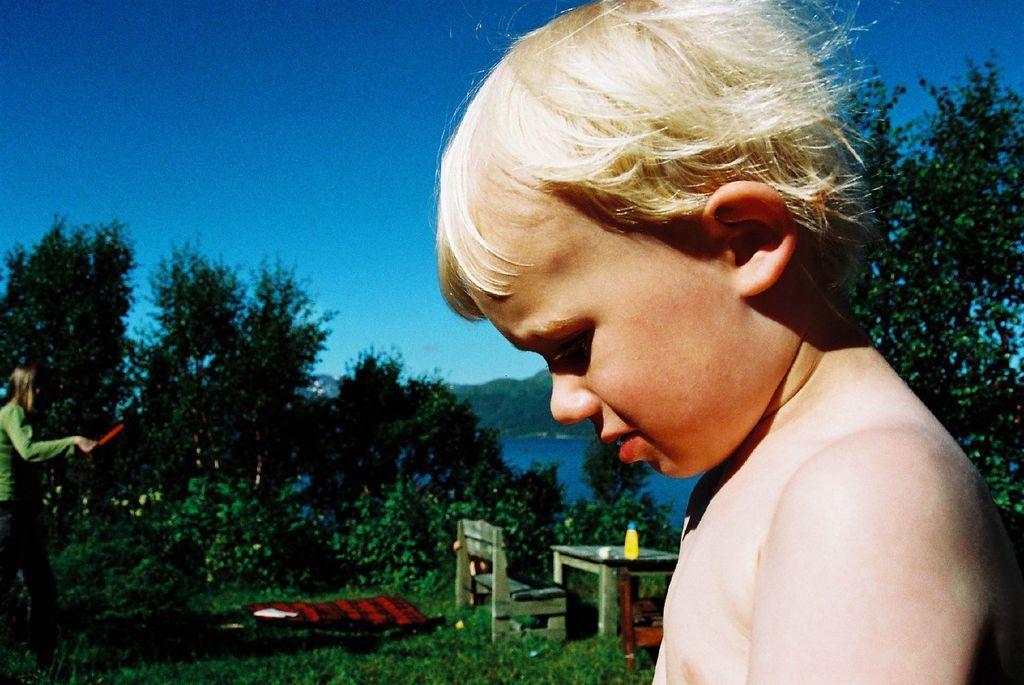Can you describe this image briefly? This picture is clicked outside and we can see the two persons and we can see the green grass, chair, table, plants and a bottle and some other objects. In the background we can see the sky, a water body and some other objects. 